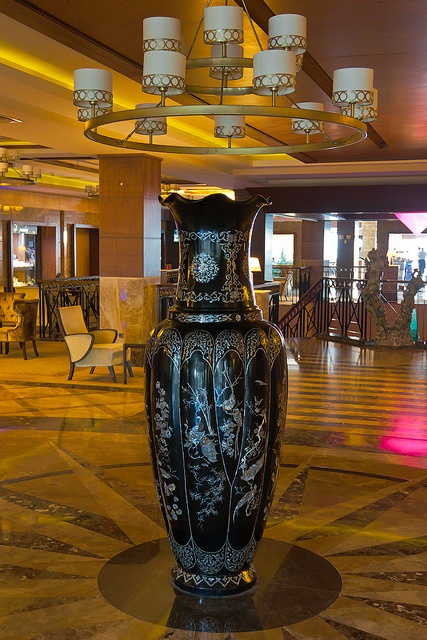Describe the objects in this image and their specific colors. I can see vase in maroon, black, gray, and olive tones, chair in maroon, olive, orange, and tan tones, and chair in maroon, black, and olive tones in this image. 